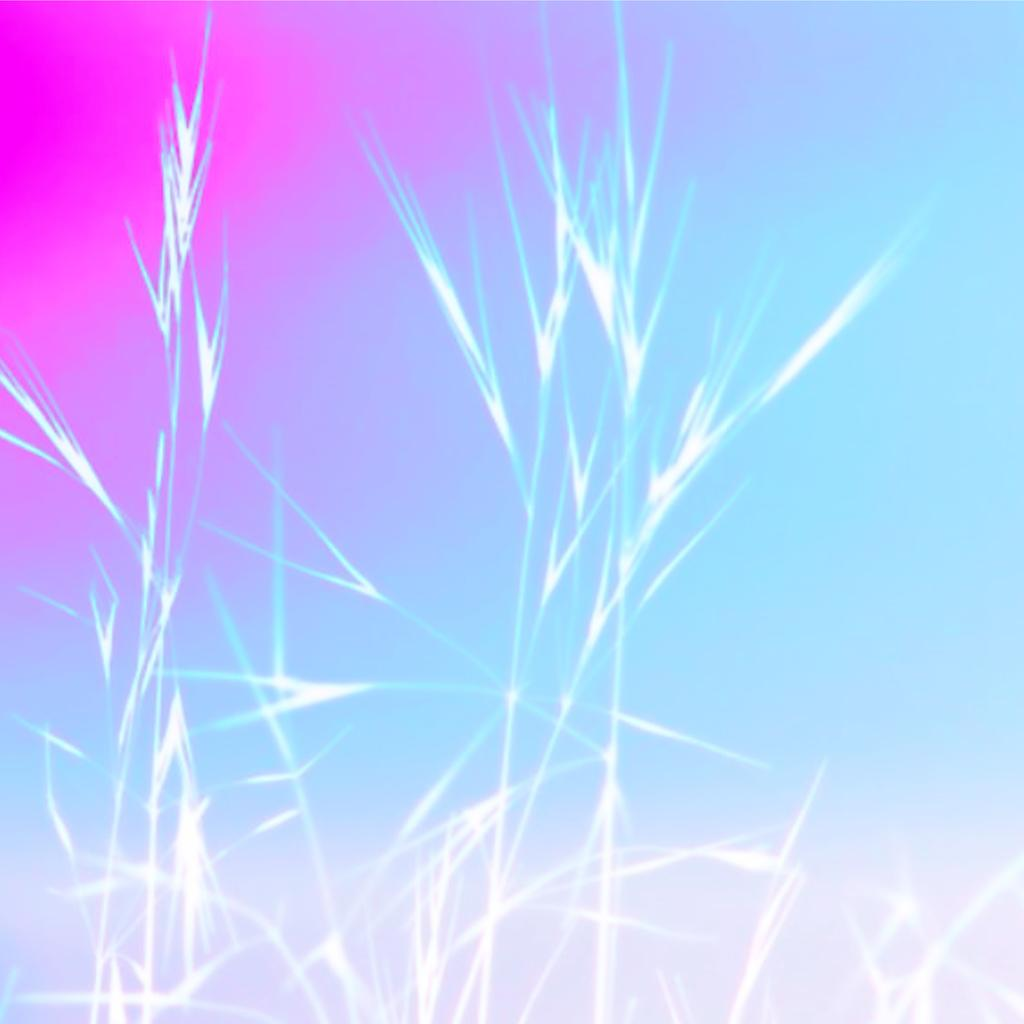What type of vegetation is visible in the image? There is grass in the image. What colors are present in the background of the image? There is a blue background and a pink background behind the grass. What invention did the father create in the image? There is no mention of a father or any invention in the image. 